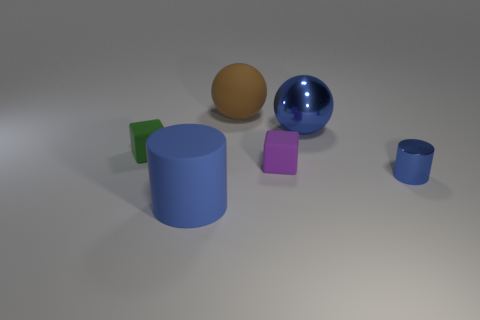What number of things are metal cylinders or brown matte things?
Your answer should be very brief. 2. What is the size of the green matte cube?
Your answer should be compact. Small. Are there fewer purple blocks than large red matte balls?
Your answer should be very brief. No. How many other rubber cylinders have the same color as the tiny cylinder?
Offer a terse response. 1. Do the large thing that is left of the large matte ball and the tiny cylinder have the same color?
Your answer should be compact. Yes. There is a big blue metallic thing that is behind the tiny green matte cube; what shape is it?
Offer a terse response. Sphere. There is a blue cylinder on the right side of the small purple matte object; are there any green matte objects that are in front of it?
Give a very brief answer. No. How many big blue cylinders have the same material as the tiny cylinder?
Offer a very short reply. 0. There is a blue metallic thing behind the tiny object that is left of the large matte thing that is in front of the purple matte thing; how big is it?
Provide a short and direct response. Large. How many green objects are to the right of the tiny blue shiny thing?
Provide a succinct answer. 0. 